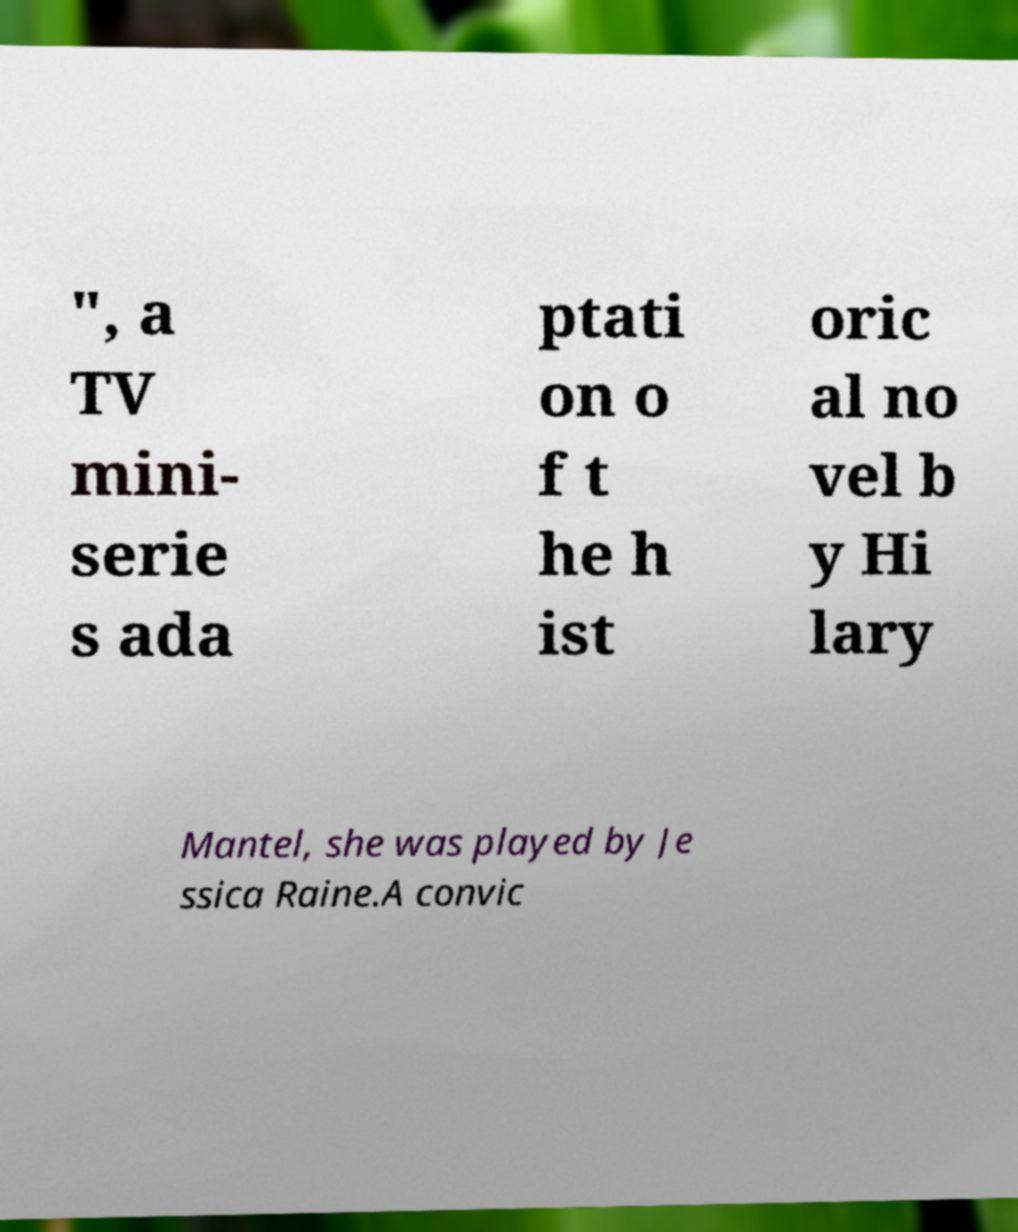Can you read and provide the text displayed in the image?This photo seems to have some interesting text. Can you extract and type it out for me? ", a TV mini- serie s ada ptati on o f t he h ist oric al no vel b y Hi lary Mantel, she was played by Je ssica Raine.A convic 